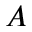<formula> <loc_0><loc_0><loc_500><loc_500>A</formula> 